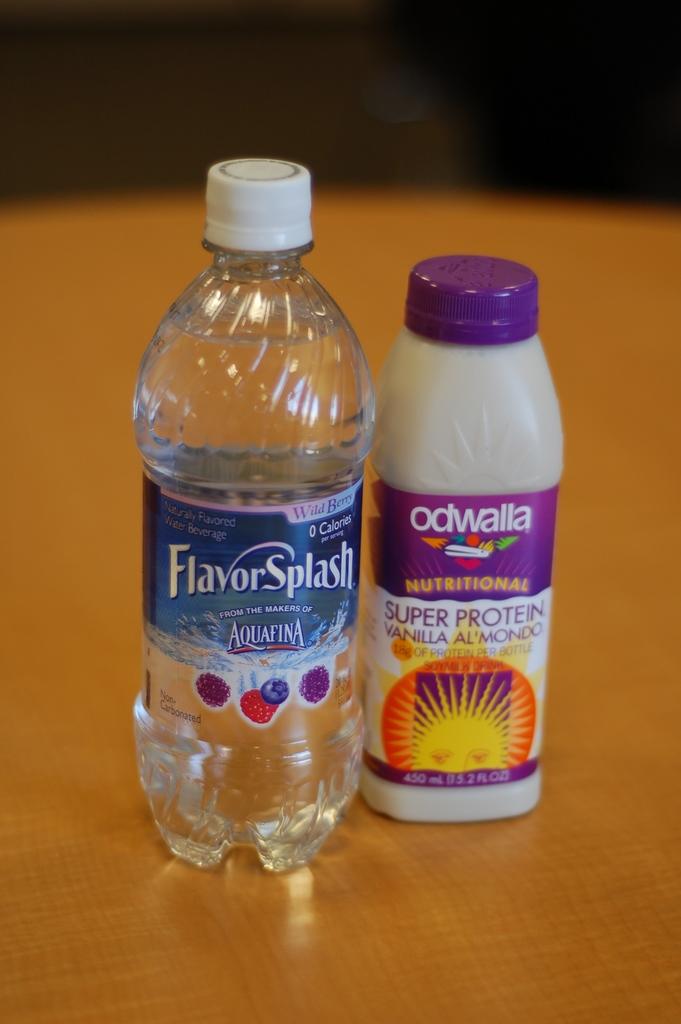What is the drink on the right?
Provide a succinct answer. Odwalla. What is the brand of water?
Ensure brevity in your answer.  Aquafina. 